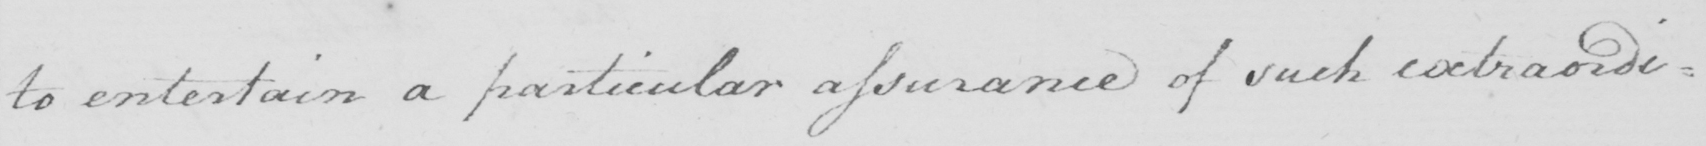What does this handwritten line say? to entertain a particular assurance of such extraordi= 